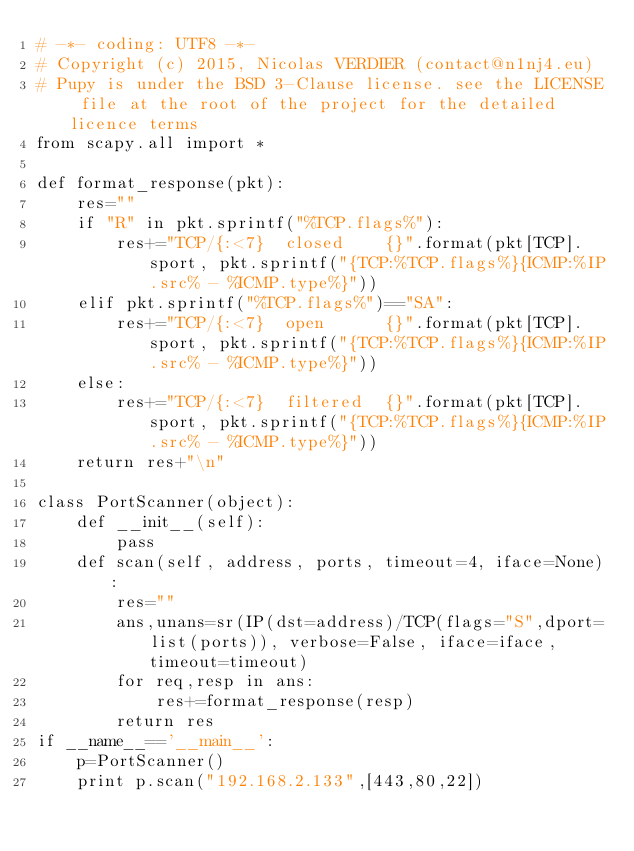<code> <loc_0><loc_0><loc_500><loc_500><_Python_># -*- coding: UTF8 -*-
# Copyright (c) 2015, Nicolas VERDIER (contact@n1nj4.eu)
# Pupy is under the BSD 3-Clause license. see the LICENSE file at the root of the project for the detailed licence terms
from scapy.all import *

def format_response(pkt):
    res=""
    if "R" in pkt.sprintf("%TCP.flags%"):
        res+="TCP/{:<7}  closed    {}".format(pkt[TCP].sport, pkt.sprintf("{TCP:%TCP.flags%}{ICMP:%IP.src% - %ICMP.type%}"))
    elif pkt.sprintf("%TCP.flags%")=="SA":
        res+="TCP/{:<7}  open      {}".format(pkt[TCP].sport, pkt.sprintf("{TCP:%TCP.flags%}{ICMP:%IP.src% - %ICMP.type%}"))
    else:
        res+="TCP/{:<7}  filtered  {}".format(pkt[TCP].sport, pkt.sprintf("{TCP:%TCP.flags%}{ICMP:%IP.src% - %ICMP.type%}"))
    return res+"\n"

class PortScanner(object):
    def __init__(self):
        pass
    def scan(self, address, ports, timeout=4, iface=None):
        res=""
        ans,unans=sr(IP(dst=address)/TCP(flags="S",dport=list(ports)), verbose=False, iface=iface, timeout=timeout)
        for req,resp in ans:
            res+=format_response(resp)
        return res
if __name__=='__main__':
    p=PortScanner()
    print p.scan("192.168.2.133",[443,80,22])

                
</code> 